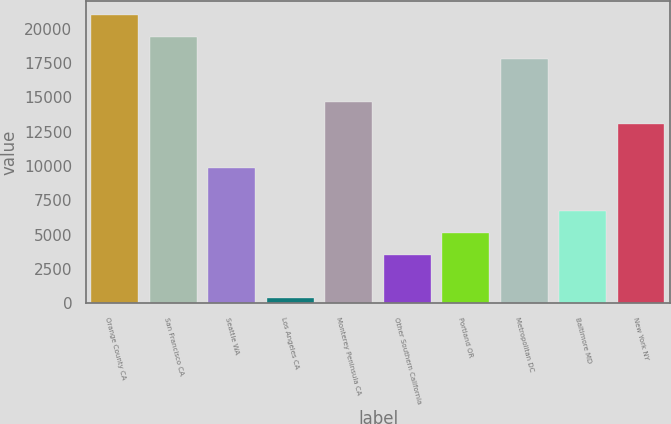<chart> <loc_0><loc_0><loc_500><loc_500><bar_chart><fcel>Orange County CA<fcel>San Francisco CA<fcel>Seattle WA<fcel>Los Angeles CA<fcel>Monterey Peninsula CA<fcel>Other Southern California<fcel>Portland OR<fcel>Metropolitan DC<fcel>Baltimore MD<fcel>New York NY<nl><fcel>20977.6<fcel>19390.4<fcel>9867.2<fcel>344<fcel>14628.8<fcel>3518.4<fcel>5105.6<fcel>17803.2<fcel>6692.8<fcel>13041.6<nl></chart> 